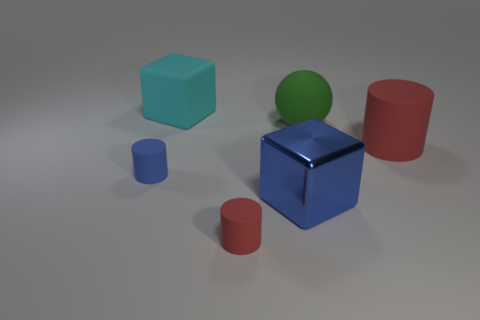Subtract all gray cylinders. Subtract all gray spheres. How many cylinders are left? 3 Add 3 yellow cylinders. How many objects exist? 9 Subtract all blocks. How many objects are left? 4 Add 3 large blue shiny objects. How many large blue shiny objects are left? 4 Add 6 large cyan rubber things. How many large cyan rubber things exist? 7 Subtract 1 cyan blocks. How many objects are left? 5 Subtract all blue metallic objects. Subtract all large matte blocks. How many objects are left? 4 